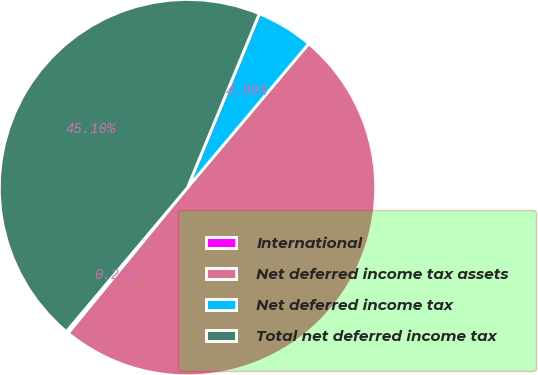Convert chart. <chart><loc_0><loc_0><loc_500><loc_500><pie_chart><fcel>International<fcel>Net deferred income tax assets<fcel>Net deferred income tax<fcel>Total net deferred income tax<nl><fcel>0.21%<fcel>49.79%<fcel>4.9%<fcel>45.1%<nl></chart> 